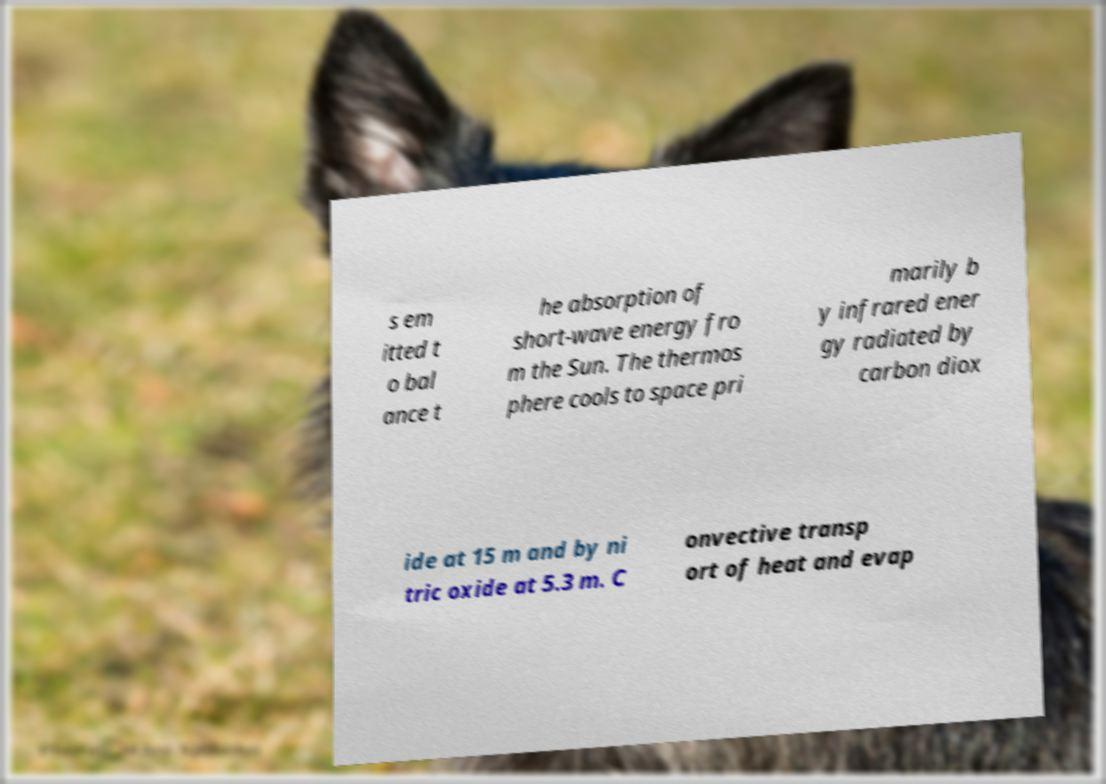Can you accurately transcribe the text from the provided image for me? s em itted t o bal ance t he absorption of short-wave energy fro m the Sun. The thermos phere cools to space pri marily b y infrared ener gy radiated by carbon diox ide at 15 m and by ni tric oxide at 5.3 m. C onvective transp ort of heat and evap 